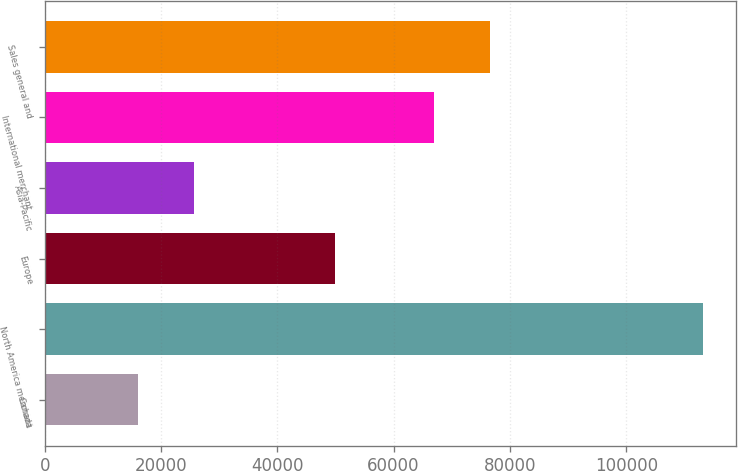<chart> <loc_0><loc_0><loc_500><loc_500><bar_chart><fcel>Canada<fcel>North America merchant<fcel>Europe<fcel>Asia-Pacific<fcel>International merchant<fcel>Sales general and<nl><fcel>15978<fcel>113265<fcel>49902<fcel>25706.7<fcel>66897<fcel>76625.7<nl></chart> 